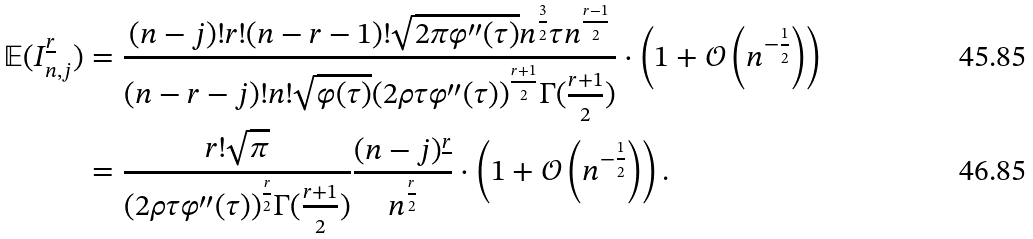Convert formula to latex. <formula><loc_0><loc_0><loc_500><loc_500>\mathbb { E } ( I _ { n , j } ^ { \underline { r } } ) & = \frac { ( n - j ) ! r ! ( n - r - 1 ) ! \sqrt { 2 \pi \varphi ^ { \prime \prime } ( \tau ) } n ^ { \frac { 3 } { 2 } } \tau n ^ { \frac { r - 1 } { 2 } } } { ( n - r - j ) ! n ! \sqrt { \varphi ( \tau ) } ( 2 \rho \tau \varphi ^ { \prime \prime } ( \tau ) ) ^ { \frac { r + 1 } { 2 } } \Gamma ( \frac { r + 1 } { 2 } ) } \cdot \left ( 1 + \mathcal { O } \left ( n ^ { - \frac { 1 } { 2 } } \right ) \right ) \\ & = \frac { r ! \sqrt { \pi } } { ( 2 \rho \tau \varphi ^ { \prime \prime } ( \tau ) ) ^ { \frac { r } { 2 } } \Gamma ( \frac { r + 1 } { 2 } ) } \frac { ( n - j ) ^ { \underline { r } } } { n ^ { \frac { r } { 2 } } } \cdot \left ( 1 + \mathcal { O } \left ( n ^ { - \frac { 1 } { 2 } } \right ) \right ) .</formula> 